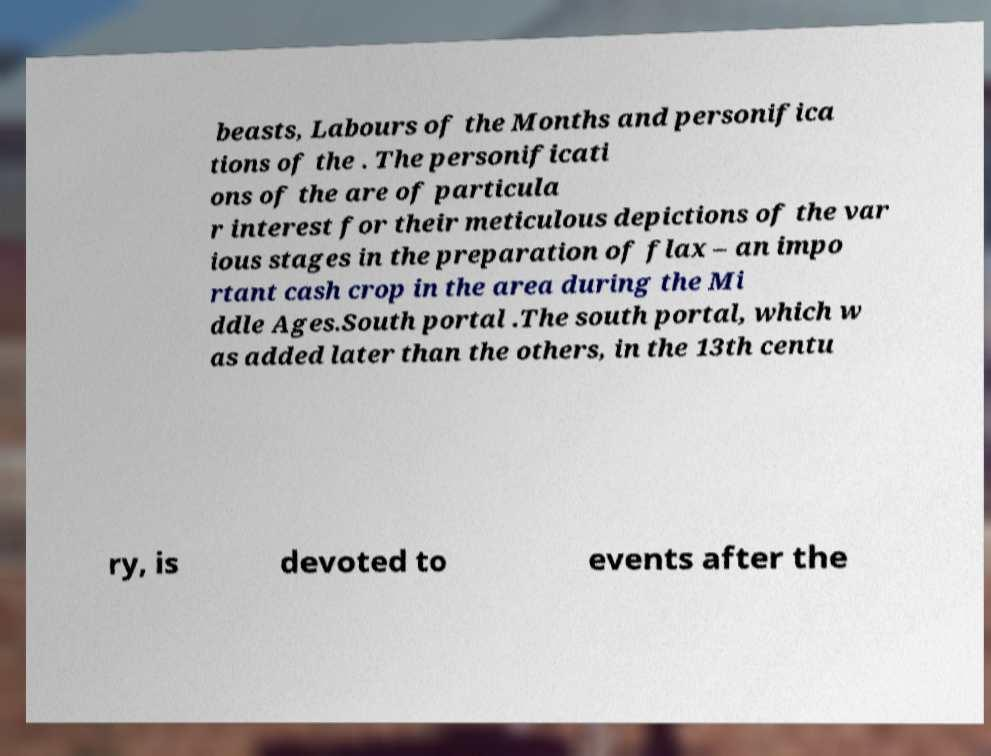Can you accurately transcribe the text from the provided image for me? beasts, Labours of the Months and personifica tions of the . The personificati ons of the are of particula r interest for their meticulous depictions of the var ious stages in the preparation of flax – an impo rtant cash crop in the area during the Mi ddle Ages.South portal .The south portal, which w as added later than the others, in the 13th centu ry, is devoted to events after the 